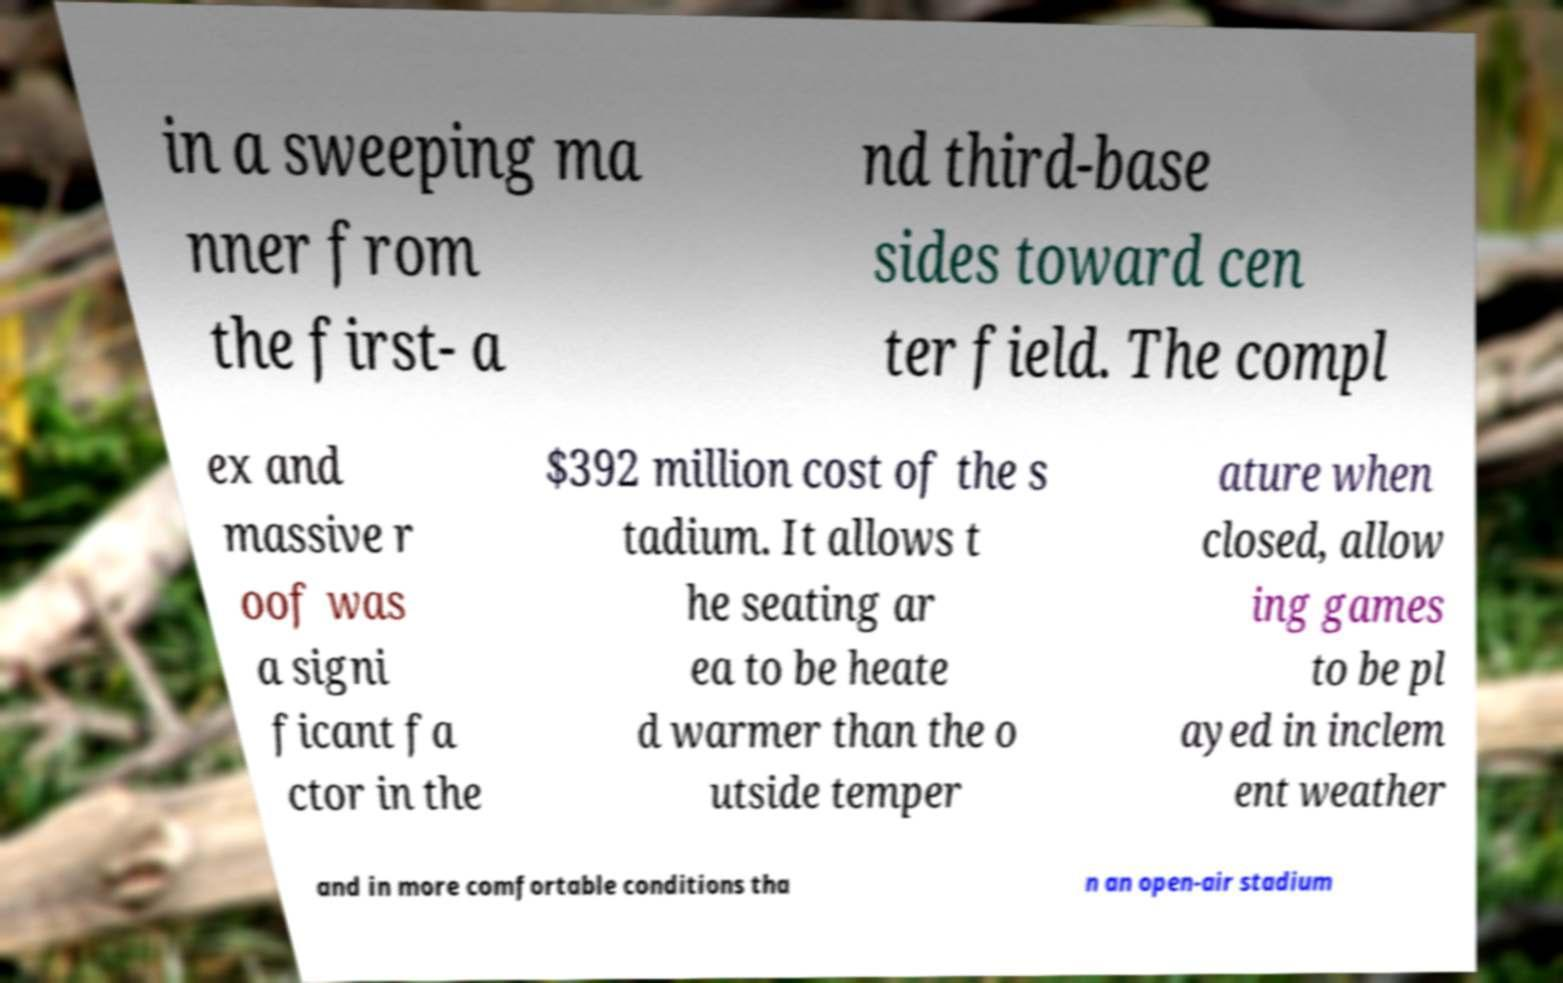Can you accurately transcribe the text from the provided image for me? in a sweeping ma nner from the first- a nd third-base sides toward cen ter field. The compl ex and massive r oof was a signi ficant fa ctor in the $392 million cost of the s tadium. It allows t he seating ar ea to be heate d warmer than the o utside temper ature when closed, allow ing games to be pl ayed in inclem ent weather and in more comfortable conditions tha n an open-air stadium 